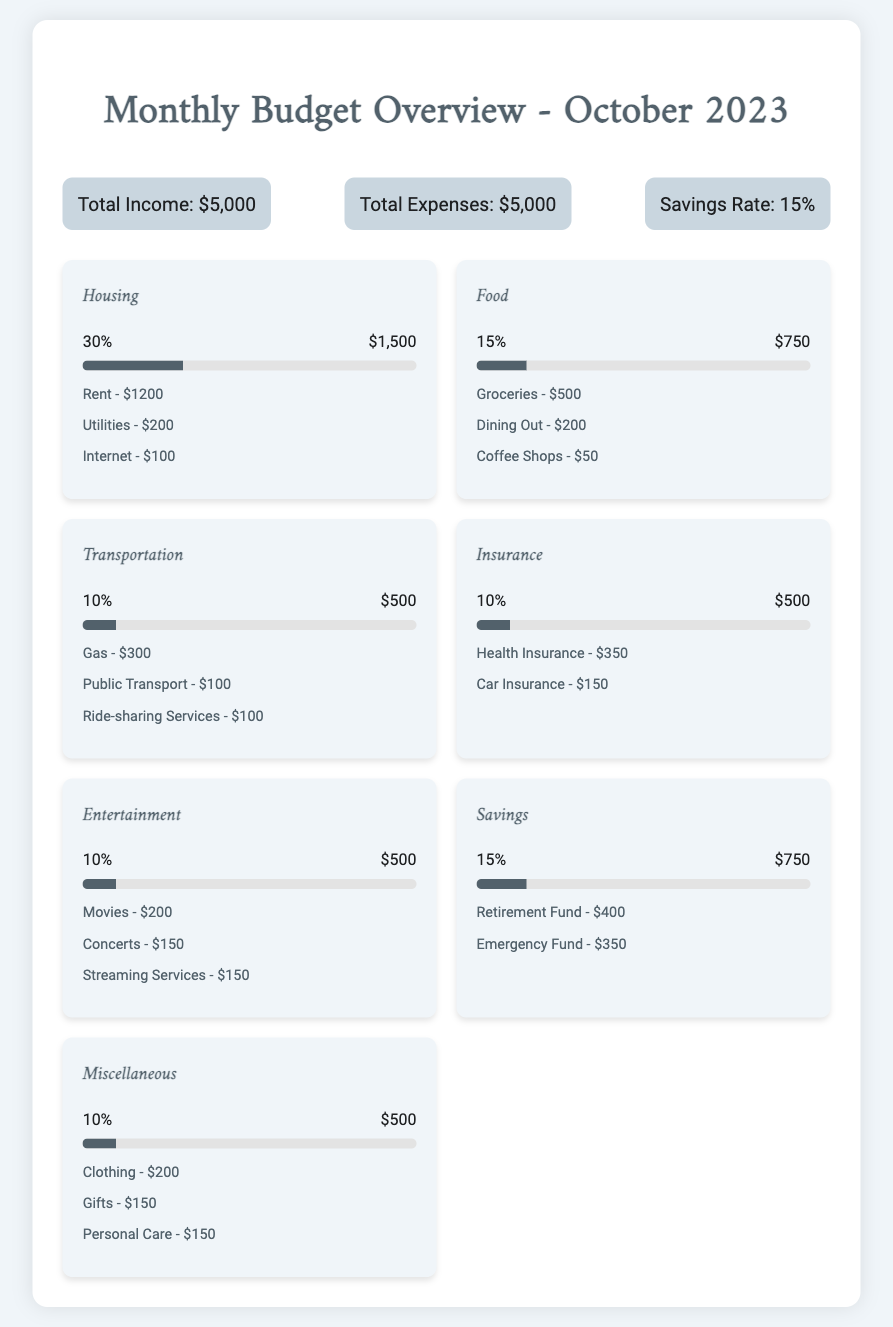What is the total income? The total income is directly stated in the summary section of the document.
Answer: $5,000 What percentage of expenses is allocated to Housing? The percentage for Housing is specified in the category section of the document.
Answer: 30% How much is spent on Food? The amount spent on Food is detailed in the category section of the document.
Answer: $750 What is the total expenses? The total expenses is shown in the summary section of the document.
Answer: $5,000 How much is allocated for Savings? The amount allocated for Savings is listed in the category section of the document.
Answer: $750 Which category has the highest spending percentage? The category with the highest percentage is identified in the document's categories.
Answer: Housing What percentage of total spending is on Entertainment? The percentage for Entertainment is specified in the category section.
Answer: 10% How much is spent on Transportation? The amount spent on Transportation is mentioned in the category details.
Answer: $500 What are examples of Miscellaneous expenses? Examples of Miscellaneous expenses are provided in the category section.
Answer: Clothing, Gifts, Personal Care 